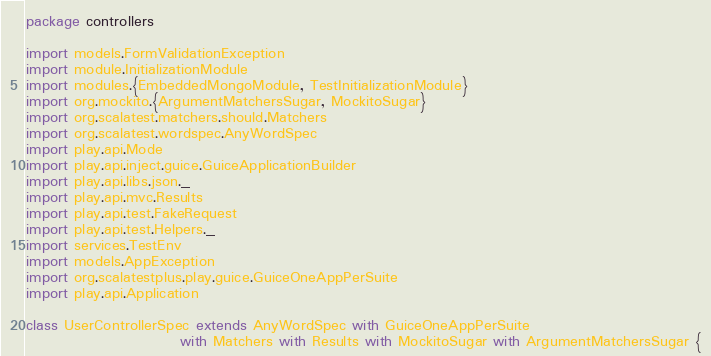<code> <loc_0><loc_0><loc_500><loc_500><_Scala_>package controllers

import models.FormValidationException
import module.InitializationModule
import modules.{EmbeddedMongoModule, TestInitializationModule}
import org.mockito.{ArgumentMatchersSugar, MockitoSugar}
import org.scalatest.matchers.should.Matchers
import org.scalatest.wordspec.AnyWordSpec
import play.api.Mode
import play.api.inject.guice.GuiceApplicationBuilder
import play.api.libs.json._
import play.api.mvc.Results
import play.api.test.FakeRequest
import play.api.test.Helpers._
import services.TestEnv
import models.AppException
import org.scalatestplus.play.guice.GuiceOneAppPerSuite
import play.api.Application

class UserControllerSpec extends AnyWordSpec with GuiceOneAppPerSuite
                          with Matchers with Results with MockitoSugar with ArgumentMatchersSugar {
</code> 